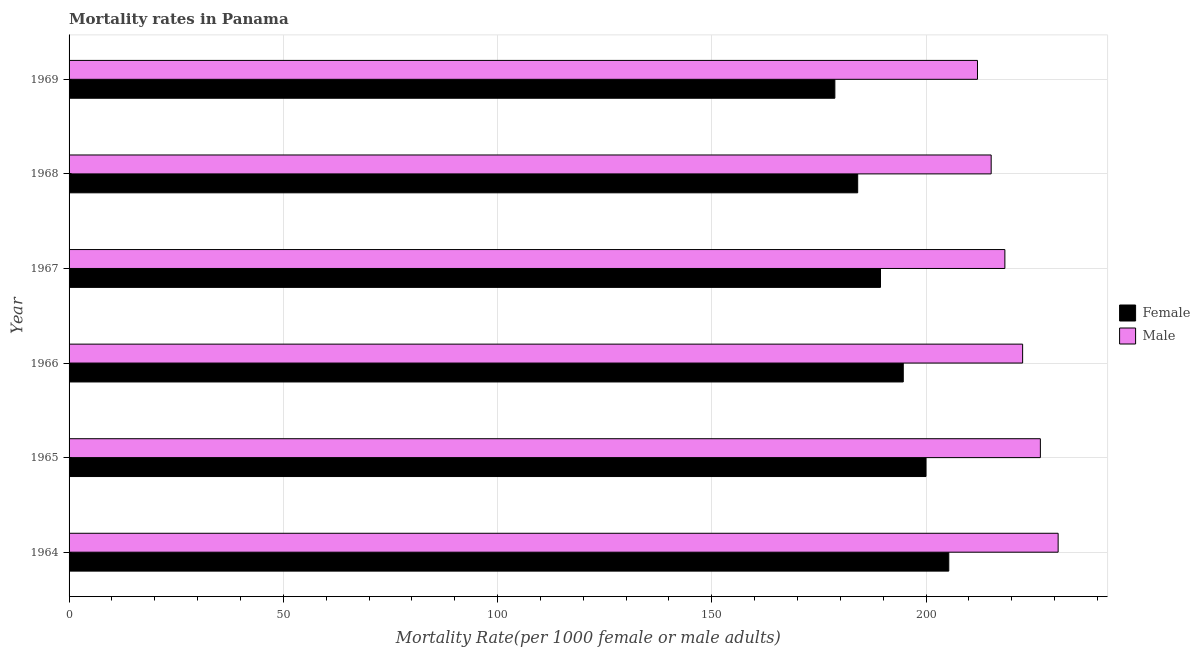How many groups of bars are there?
Provide a short and direct response. 6. How many bars are there on the 2nd tick from the bottom?
Keep it short and to the point. 2. What is the label of the 5th group of bars from the top?
Offer a terse response. 1965. What is the female mortality rate in 1967?
Provide a succinct answer. 189.37. Across all years, what is the maximum female mortality rate?
Your response must be concise. 205.3. Across all years, what is the minimum female mortality rate?
Ensure brevity in your answer.  178.71. In which year was the female mortality rate maximum?
Make the answer very short. 1964. In which year was the male mortality rate minimum?
Make the answer very short. 1969. What is the total female mortality rate in the graph?
Offer a very short reply. 1152.08. What is the difference between the male mortality rate in 1965 and that in 1967?
Offer a terse response. 8.29. What is the difference between the female mortality rate in 1964 and the male mortality rate in 1969?
Provide a short and direct response. -6.7. What is the average female mortality rate per year?
Provide a short and direct response. 192.01. In the year 1966, what is the difference between the female mortality rate and male mortality rate?
Offer a very short reply. -27.86. In how many years, is the male mortality rate greater than 140 ?
Your answer should be compact. 6. What is the ratio of the male mortality rate in 1964 to that in 1969?
Ensure brevity in your answer.  1.09. Is the difference between the female mortality rate in 1967 and 1969 greater than the difference between the male mortality rate in 1967 and 1969?
Your response must be concise. Yes. What is the difference between the highest and the second highest female mortality rate?
Provide a succinct answer. 5.31. What is the difference between the highest and the lowest female mortality rate?
Offer a very short reply. 26.59. Is the sum of the female mortality rate in 1964 and 1965 greater than the maximum male mortality rate across all years?
Keep it short and to the point. Yes. What does the 2nd bar from the top in 1967 represents?
Make the answer very short. Female. How many bars are there?
Offer a very short reply. 12. Are all the bars in the graph horizontal?
Provide a succinct answer. Yes. How many years are there in the graph?
Your answer should be compact. 6. Are the values on the major ticks of X-axis written in scientific E-notation?
Your answer should be very brief. No. Does the graph contain any zero values?
Your answer should be compact. No. Where does the legend appear in the graph?
Provide a short and direct response. Center right. What is the title of the graph?
Your answer should be very brief. Mortality rates in Panama. What is the label or title of the X-axis?
Your response must be concise. Mortality Rate(per 1000 female or male adults). What is the label or title of the Y-axis?
Your response must be concise. Year. What is the Mortality Rate(per 1000 female or male adults) in Female in 1964?
Your response must be concise. 205.3. What is the Mortality Rate(per 1000 female or male adults) of Male in 1964?
Give a very brief answer. 230.82. What is the Mortality Rate(per 1000 female or male adults) in Female in 1965?
Ensure brevity in your answer.  199.99. What is the Mortality Rate(per 1000 female or male adults) of Male in 1965?
Your answer should be compact. 226.68. What is the Mortality Rate(per 1000 female or male adults) in Female in 1966?
Your answer should be very brief. 194.68. What is the Mortality Rate(per 1000 female or male adults) in Male in 1966?
Your answer should be very brief. 222.53. What is the Mortality Rate(per 1000 female or male adults) in Female in 1967?
Provide a succinct answer. 189.37. What is the Mortality Rate(per 1000 female or male adults) of Male in 1967?
Offer a terse response. 218.39. What is the Mortality Rate(per 1000 female or male adults) of Female in 1968?
Offer a very short reply. 184.04. What is the Mortality Rate(per 1000 female or male adults) in Male in 1968?
Give a very brief answer. 215.19. What is the Mortality Rate(per 1000 female or male adults) in Female in 1969?
Make the answer very short. 178.71. What is the Mortality Rate(per 1000 female or male adults) in Male in 1969?
Your answer should be compact. 212. Across all years, what is the maximum Mortality Rate(per 1000 female or male adults) in Female?
Keep it short and to the point. 205.3. Across all years, what is the maximum Mortality Rate(per 1000 female or male adults) in Male?
Make the answer very short. 230.82. Across all years, what is the minimum Mortality Rate(per 1000 female or male adults) in Female?
Ensure brevity in your answer.  178.71. Across all years, what is the minimum Mortality Rate(per 1000 female or male adults) in Male?
Offer a very short reply. 212. What is the total Mortality Rate(per 1000 female or male adults) in Female in the graph?
Offer a terse response. 1152.08. What is the total Mortality Rate(per 1000 female or male adults) in Male in the graph?
Provide a short and direct response. 1325.61. What is the difference between the Mortality Rate(per 1000 female or male adults) of Female in 1964 and that in 1965?
Make the answer very short. 5.31. What is the difference between the Mortality Rate(per 1000 female or male adults) of Male in 1964 and that in 1965?
Ensure brevity in your answer.  4.14. What is the difference between the Mortality Rate(per 1000 female or male adults) of Female in 1964 and that in 1966?
Offer a terse response. 10.62. What is the difference between the Mortality Rate(per 1000 female or male adults) in Male in 1964 and that in 1966?
Offer a very short reply. 8.29. What is the difference between the Mortality Rate(per 1000 female or male adults) of Female in 1964 and that in 1967?
Ensure brevity in your answer.  15.93. What is the difference between the Mortality Rate(per 1000 female or male adults) of Male in 1964 and that in 1967?
Offer a terse response. 12.43. What is the difference between the Mortality Rate(per 1000 female or male adults) of Female in 1964 and that in 1968?
Provide a short and direct response. 21.26. What is the difference between the Mortality Rate(per 1000 female or male adults) of Male in 1964 and that in 1968?
Give a very brief answer. 15.62. What is the difference between the Mortality Rate(per 1000 female or male adults) in Female in 1964 and that in 1969?
Make the answer very short. 26.59. What is the difference between the Mortality Rate(per 1000 female or male adults) in Male in 1964 and that in 1969?
Your response must be concise. 18.82. What is the difference between the Mortality Rate(per 1000 female or male adults) in Female in 1965 and that in 1966?
Make the answer very short. 5.31. What is the difference between the Mortality Rate(per 1000 female or male adults) of Male in 1965 and that in 1966?
Ensure brevity in your answer.  4.14. What is the difference between the Mortality Rate(per 1000 female or male adults) in Female in 1965 and that in 1967?
Offer a terse response. 10.62. What is the difference between the Mortality Rate(per 1000 female or male adults) of Male in 1965 and that in 1967?
Your answer should be compact. 8.29. What is the difference between the Mortality Rate(per 1000 female or male adults) of Female in 1965 and that in 1968?
Your response must be concise. 15.95. What is the difference between the Mortality Rate(per 1000 female or male adults) of Male in 1965 and that in 1968?
Ensure brevity in your answer.  11.48. What is the difference between the Mortality Rate(per 1000 female or male adults) of Female in 1965 and that in 1969?
Keep it short and to the point. 21.27. What is the difference between the Mortality Rate(per 1000 female or male adults) in Male in 1965 and that in 1969?
Ensure brevity in your answer.  14.68. What is the difference between the Mortality Rate(per 1000 female or male adults) in Female in 1966 and that in 1967?
Your answer should be very brief. 5.31. What is the difference between the Mortality Rate(per 1000 female or male adults) of Male in 1966 and that in 1967?
Provide a short and direct response. 4.14. What is the difference between the Mortality Rate(per 1000 female or male adults) in Female in 1966 and that in 1968?
Give a very brief answer. 10.64. What is the difference between the Mortality Rate(per 1000 female or male adults) of Male in 1966 and that in 1968?
Your response must be concise. 7.34. What is the difference between the Mortality Rate(per 1000 female or male adults) of Female in 1966 and that in 1969?
Offer a terse response. 15.96. What is the difference between the Mortality Rate(per 1000 female or male adults) in Male in 1966 and that in 1969?
Provide a succinct answer. 10.54. What is the difference between the Mortality Rate(per 1000 female or male adults) of Female in 1967 and that in 1968?
Provide a short and direct response. 5.33. What is the difference between the Mortality Rate(per 1000 female or male adults) in Male in 1967 and that in 1968?
Make the answer very short. 3.2. What is the difference between the Mortality Rate(per 1000 female or male adults) in Female in 1967 and that in 1969?
Give a very brief answer. 10.65. What is the difference between the Mortality Rate(per 1000 female or male adults) in Male in 1967 and that in 1969?
Make the answer very short. 6.39. What is the difference between the Mortality Rate(per 1000 female or male adults) in Female in 1968 and that in 1969?
Provide a short and direct response. 5.33. What is the difference between the Mortality Rate(per 1000 female or male adults) in Male in 1968 and that in 1969?
Provide a succinct answer. 3.2. What is the difference between the Mortality Rate(per 1000 female or male adults) in Female in 1964 and the Mortality Rate(per 1000 female or male adults) in Male in 1965?
Offer a terse response. -21.38. What is the difference between the Mortality Rate(per 1000 female or male adults) of Female in 1964 and the Mortality Rate(per 1000 female or male adults) of Male in 1966?
Offer a very short reply. -17.24. What is the difference between the Mortality Rate(per 1000 female or male adults) of Female in 1964 and the Mortality Rate(per 1000 female or male adults) of Male in 1967?
Your answer should be compact. -13.09. What is the difference between the Mortality Rate(per 1000 female or male adults) of Female in 1964 and the Mortality Rate(per 1000 female or male adults) of Male in 1968?
Make the answer very short. -9.9. What is the difference between the Mortality Rate(per 1000 female or male adults) in Female in 1964 and the Mortality Rate(per 1000 female or male adults) in Male in 1969?
Offer a terse response. -6.7. What is the difference between the Mortality Rate(per 1000 female or male adults) in Female in 1965 and the Mortality Rate(per 1000 female or male adults) in Male in 1966?
Provide a succinct answer. -22.55. What is the difference between the Mortality Rate(per 1000 female or male adults) in Female in 1965 and the Mortality Rate(per 1000 female or male adults) in Male in 1967?
Your answer should be very brief. -18.4. What is the difference between the Mortality Rate(per 1000 female or male adults) of Female in 1965 and the Mortality Rate(per 1000 female or male adults) of Male in 1968?
Make the answer very short. -15.21. What is the difference between the Mortality Rate(per 1000 female or male adults) in Female in 1965 and the Mortality Rate(per 1000 female or male adults) in Male in 1969?
Give a very brief answer. -12.01. What is the difference between the Mortality Rate(per 1000 female or male adults) in Female in 1966 and the Mortality Rate(per 1000 female or male adults) in Male in 1967?
Provide a succinct answer. -23.71. What is the difference between the Mortality Rate(per 1000 female or male adults) of Female in 1966 and the Mortality Rate(per 1000 female or male adults) of Male in 1968?
Make the answer very short. -20.52. What is the difference between the Mortality Rate(per 1000 female or male adults) in Female in 1966 and the Mortality Rate(per 1000 female or male adults) in Male in 1969?
Offer a very short reply. -17.32. What is the difference between the Mortality Rate(per 1000 female or male adults) of Female in 1967 and the Mortality Rate(per 1000 female or male adults) of Male in 1968?
Provide a short and direct response. -25.83. What is the difference between the Mortality Rate(per 1000 female or male adults) of Female in 1967 and the Mortality Rate(per 1000 female or male adults) of Male in 1969?
Provide a short and direct response. -22.63. What is the difference between the Mortality Rate(per 1000 female or male adults) of Female in 1968 and the Mortality Rate(per 1000 female or male adults) of Male in 1969?
Offer a terse response. -27.96. What is the average Mortality Rate(per 1000 female or male adults) of Female per year?
Your answer should be very brief. 192.01. What is the average Mortality Rate(per 1000 female or male adults) in Male per year?
Keep it short and to the point. 220.93. In the year 1964, what is the difference between the Mortality Rate(per 1000 female or male adults) of Female and Mortality Rate(per 1000 female or male adults) of Male?
Provide a short and direct response. -25.52. In the year 1965, what is the difference between the Mortality Rate(per 1000 female or male adults) of Female and Mortality Rate(per 1000 female or male adults) of Male?
Your answer should be compact. -26.69. In the year 1966, what is the difference between the Mortality Rate(per 1000 female or male adults) of Female and Mortality Rate(per 1000 female or male adults) of Male?
Make the answer very short. -27.86. In the year 1967, what is the difference between the Mortality Rate(per 1000 female or male adults) of Female and Mortality Rate(per 1000 female or male adults) of Male?
Keep it short and to the point. -29.02. In the year 1968, what is the difference between the Mortality Rate(per 1000 female or male adults) of Female and Mortality Rate(per 1000 female or male adults) of Male?
Ensure brevity in your answer.  -31.15. In the year 1969, what is the difference between the Mortality Rate(per 1000 female or male adults) of Female and Mortality Rate(per 1000 female or male adults) of Male?
Offer a very short reply. -33.28. What is the ratio of the Mortality Rate(per 1000 female or male adults) of Female in 1964 to that in 1965?
Offer a terse response. 1.03. What is the ratio of the Mortality Rate(per 1000 female or male adults) of Male in 1964 to that in 1965?
Provide a short and direct response. 1.02. What is the ratio of the Mortality Rate(per 1000 female or male adults) in Female in 1964 to that in 1966?
Your answer should be very brief. 1.05. What is the ratio of the Mortality Rate(per 1000 female or male adults) in Male in 1964 to that in 1966?
Keep it short and to the point. 1.04. What is the ratio of the Mortality Rate(per 1000 female or male adults) of Female in 1964 to that in 1967?
Your answer should be compact. 1.08. What is the ratio of the Mortality Rate(per 1000 female or male adults) of Male in 1964 to that in 1967?
Keep it short and to the point. 1.06. What is the ratio of the Mortality Rate(per 1000 female or male adults) in Female in 1964 to that in 1968?
Offer a very short reply. 1.12. What is the ratio of the Mortality Rate(per 1000 female or male adults) in Male in 1964 to that in 1968?
Keep it short and to the point. 1.07. What is the ratio of the Mortality Rate(per 1000 female or male adults) in Female in 1964 to that in 1969?
Your answer should be very brief. 1.15. What is the ratio of the Mortality Rate(per 1000 female or male adults) of Male in 1964 to that in 1969?
Your response must be concise. 1.09. What is the ratio of the Mortality Rate(per 1000 female or male adults) of Female in 1965 to that in 1966?
Provide a succinct answer. 1.03. What is the ratio of the Mortality Rate(per 1000 female or male adults) in Male in 1965 to that in 1966?
Your answer should be compact. 1.02. What is the ratio of the Mortality Rate(per 1000 female or male adults) of Female in 1965 to that in 1967?
Make the answer very short. 1.06. What is the ratio of the Mortality Rate(per 1000 female or male adults) of Male in 1965 to that in 1967?
Give a very brief answer. 1.04. What is the ratio of the Mortality Rate(per 1000 female or male adults) of Female in 1965 to that in 1968?
Your response must be concise. 1.09. What is the ratio of the Mortality Rate(per 1000 female or male adults) in Male in 1965 to that in 1968?
Make the answer very short. 1.05. What is the ratio of the Mortality Rate(per 1000 female or male adults) in Female in 1965 to that in 1969?
Your answer should be compact. 1.12. What is the ratio of the Mortality Rate(per 1000 female or male adults) in Male in 1965 to that in 1969?
Your response must be concise. 1.07. What is the ratio of the Mortality Rate(per 1000 female or male adults) in Female in 1966 to that in 1967?
Provide a succinct answer. 1.03. What is the ratio of the Mortality Rate(per 1000 female or male adults) of Female in 1966 to that in 1968?
Keep it short and to the point. 1.06. What is the ratio of the Mortality Rate(per 1000 female or male adults) of Male in 1966 to that in 1968?
Offer a terse response. 1.03. What is the ratio of the Mortality Rate(per 1000 female or male adults) in Female in 1966 to that in 1969?
Your response must be concise. 1.09. What is the ratio of the Mortality Rate(per 1000 female or male adults) of Male in 1966 to that in 1969?
Offer a very short reply. 1.05. What is the ratio of the Mortality Rate(per 1000 female or male adults) in Female in 1967 to that in 1968?
Your response must be concise. 1.03. What is the ratio of the Mortality Rate(per 1000 female or male adults) of Male in 1967 to that in 1968?
Ensure brevity in your answer.  1.01. What is the ratio of the Mortality Rate(per 1000 female or male adults) in Female in 1967 to that in 1969?
Offer a terse response. 1.06. What is the ratio of the Mortality Rate(per 1000 female or male adults) of Male in 1967 to that in 1969?
Your response must be concise. 1.03. What is the ratio of the Mortality Rate(per 1000 female or male adults) in Female in 1968 to that in 1969?
Keep it short and to the point. 1.03. What is the ratio of the Mortality Rate(per 1000 female or male adults) in Male in 1968 to that in 1969?
Your answer should be compact. 1.02. What is the difference between the highest and the second highest Mortality Rate(per 1000 female or male adults) in Female?
Keep it short and to the point. 5.31. What is the difference between the highest and the second highest Mortality Rate(per 1000 female or male adults) in Male?
Offer a very short reply. 4.14. What is the difference between the highest and the lowest Mortality Rate(per 1000 female or male adults) in Female?
Your response must be concise. 26.59. What is the difference between the highest and the lowest Mortality Rate(per 1000 female or male adults) of Male?
Give a very brief answer. 18.82. 